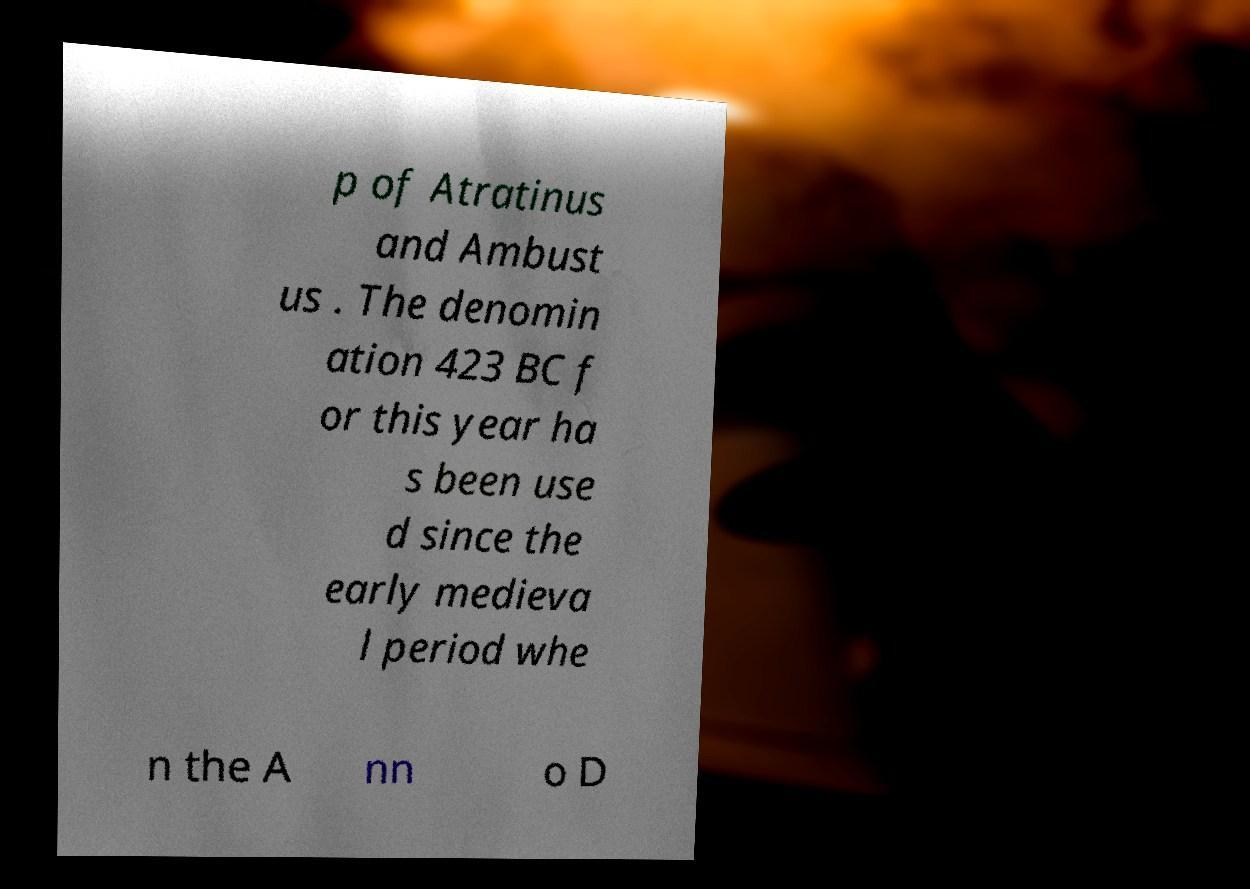There's text embedded in this image that I need extracted. Can you transcribe it verbatim? p of Atratinus and Ambust us . The denomin ation 423 BC f or this year ha s been use d since the early medieva l period whe n the A nn o D 